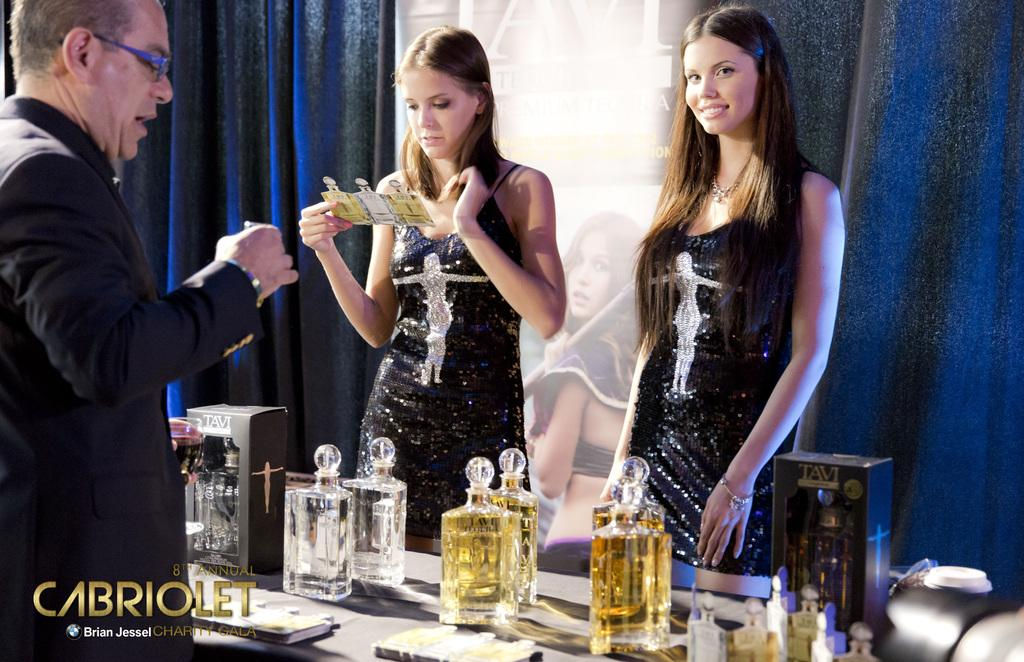<image>
Provide a brief description of the given image. Advertisement showing a woman serving alcohol and the word CABRIOLET near the bottom. 